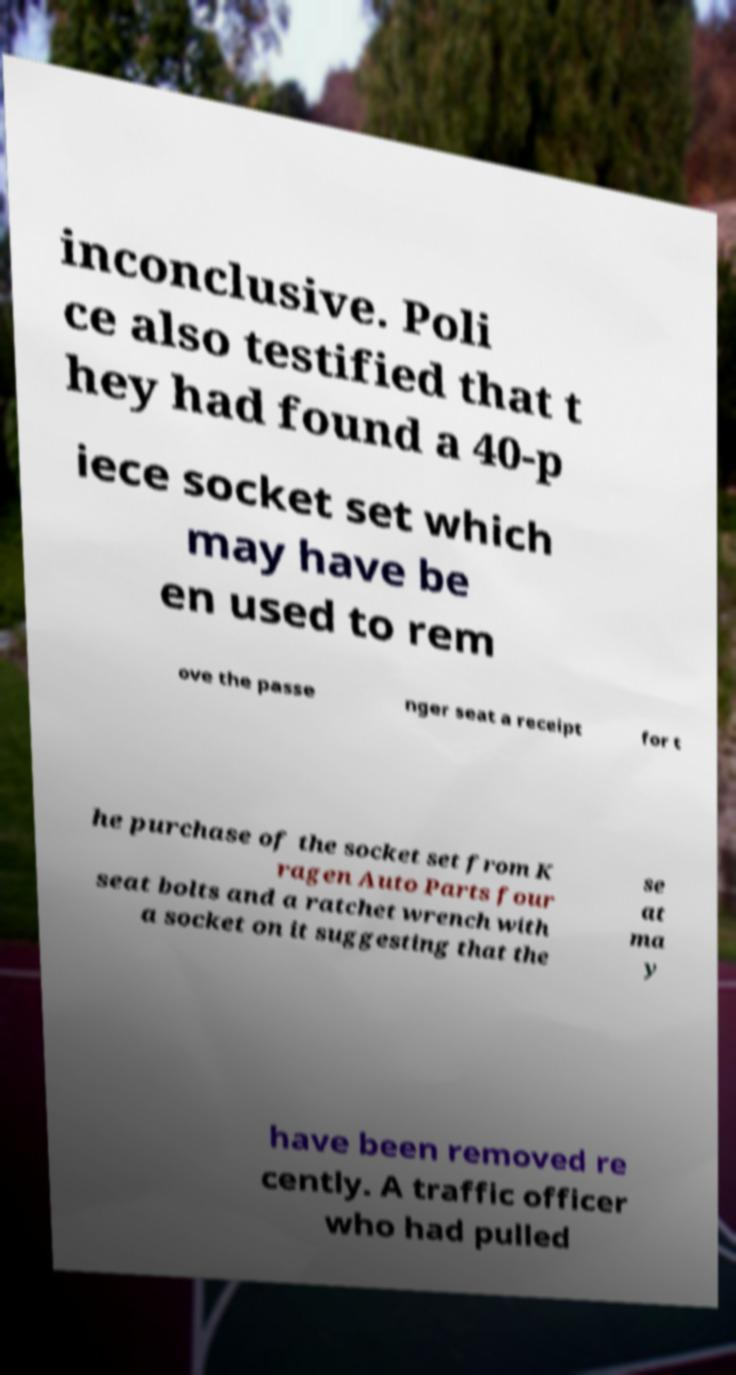There's text embedded in this image that I need extracted. Can you transcribe it verbatim? inconclusive. Poli ce also testified that t hey had found a 40-p iece socket set which may have be en used to rem ove the passe nger seat a receipt for t he purchase of the socket set from K ragen Auto Parts four seat bolts and a ratchet wrench with a socket on it suggesting that the se at ma y have been removed re cently. A traffic officer who had pulled 